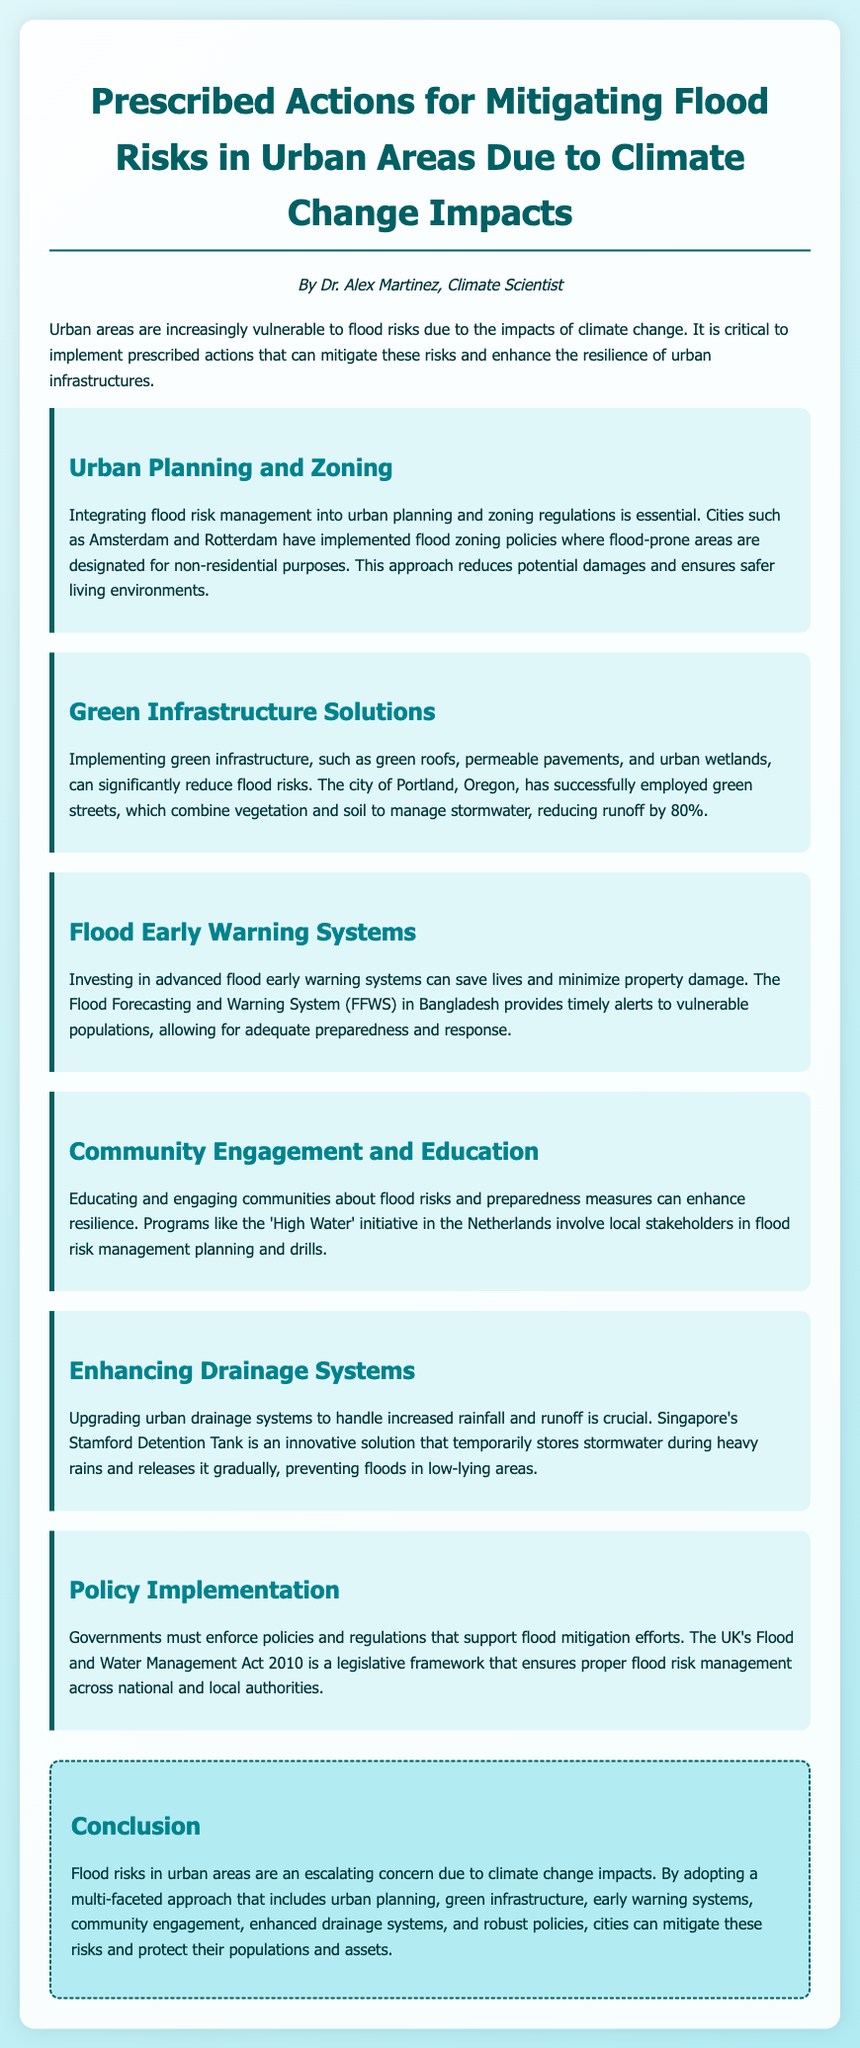What is the main focus of the document? The document focuses on actions for mitigating flood risks in urban areas due to climate change impacts.
Answer: Mitigating flood risks in urban areas Who is the author of the document? The author of the document is introduced in the author section as Dr. Alex Martinez.
Answer: Dr. Alex Martinez What is one example of a green infrastructure solution mentioned? The document mentions green roofs, permeable pavements, and urban wetlands as examples of green infrastructure solutions.
Answer: Green roofs Which city implemented the Flood Forecasting and Warning System? The document specifies that Bangladesh employs the Flood Forecasting and Warning System (FFWS) for flood early warning.
Answer: Bangladesh What is the name of the UK legislative framework for flood risk management? The document states that the UK's Flood and Water Management Act 2010 is the legislative framework for flood risk management.
Answer: Flood and Water Management Act 2010 What percentage of runoff reduction was achieved by Portland's green streets? The document indicates that Portland's green streets reduced runoff by 80%.
Answer: 80% What type of community program is mentioned in the document? The program described in the document is the 'High Water' initiative in the Netherlands, which involves local stakeholders.
Answer: 'High Water' initiative What is a key feature of Singapore's Stamford Detention Tank? The document highlights that Stamford Detention Tank temporarily stores stormwater during heavy rains.
Answer: Temporarily stores stormwater 